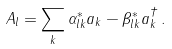Convert formula to latex. <formula><loc_0><loc_0><loc_500><loc_500>A _ { l } = \sum _ { k } \alpha ^ { * } _ { l k } a _ { k } - \beta ^ { * } _ { l k } a ^ { \dagger } _ { k } \, .</formula> 